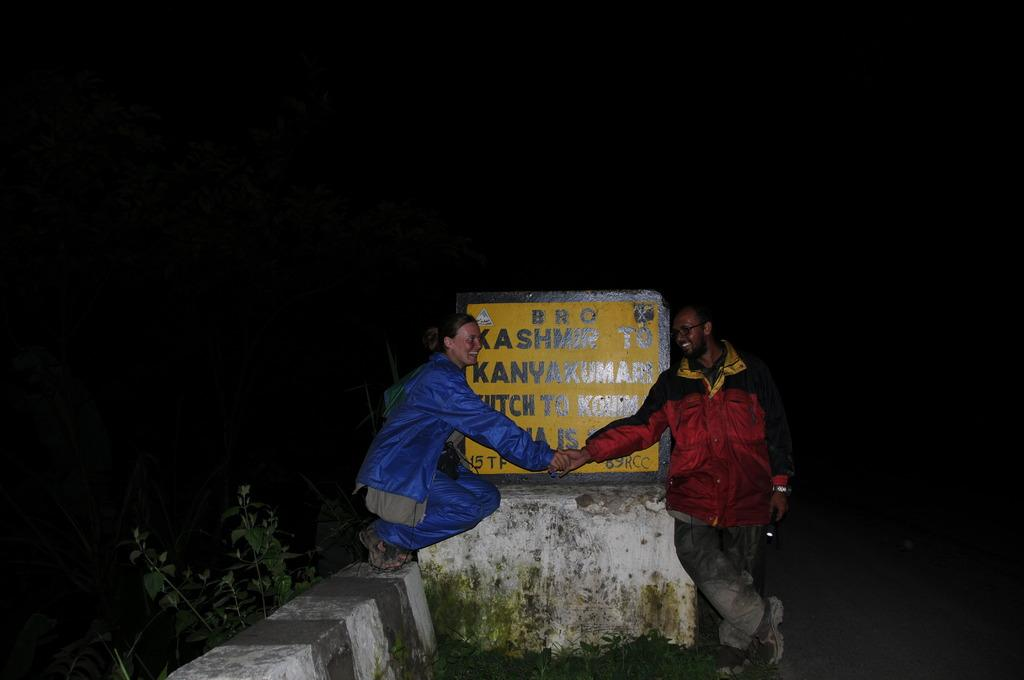What type of living organisms can be seen in the image? Plants can be seen in the image. What architectural feature is present in the image? There is a road divider in the image. Are there any human subjects in the image? Yes, there are people in the image. What is written or depicted on the stone in the image? There is information on a stone in the image. How would you describe the lighting conditions in the image? The background of the image is dark. Can you tell me how many combs are being used by the people in the image? There is no information about combs in the image; it features plants, a road divider, people, information on a stone, and a dark background. How many thumbs are visible on the people in the image? There is no specific focus on thumbs in the image; it simply shows people in a general context. Are there any tickets visible in the image? There is no mention of tickets in the image; it features plants, a road divider, people, information on a stone, and a dark background. 